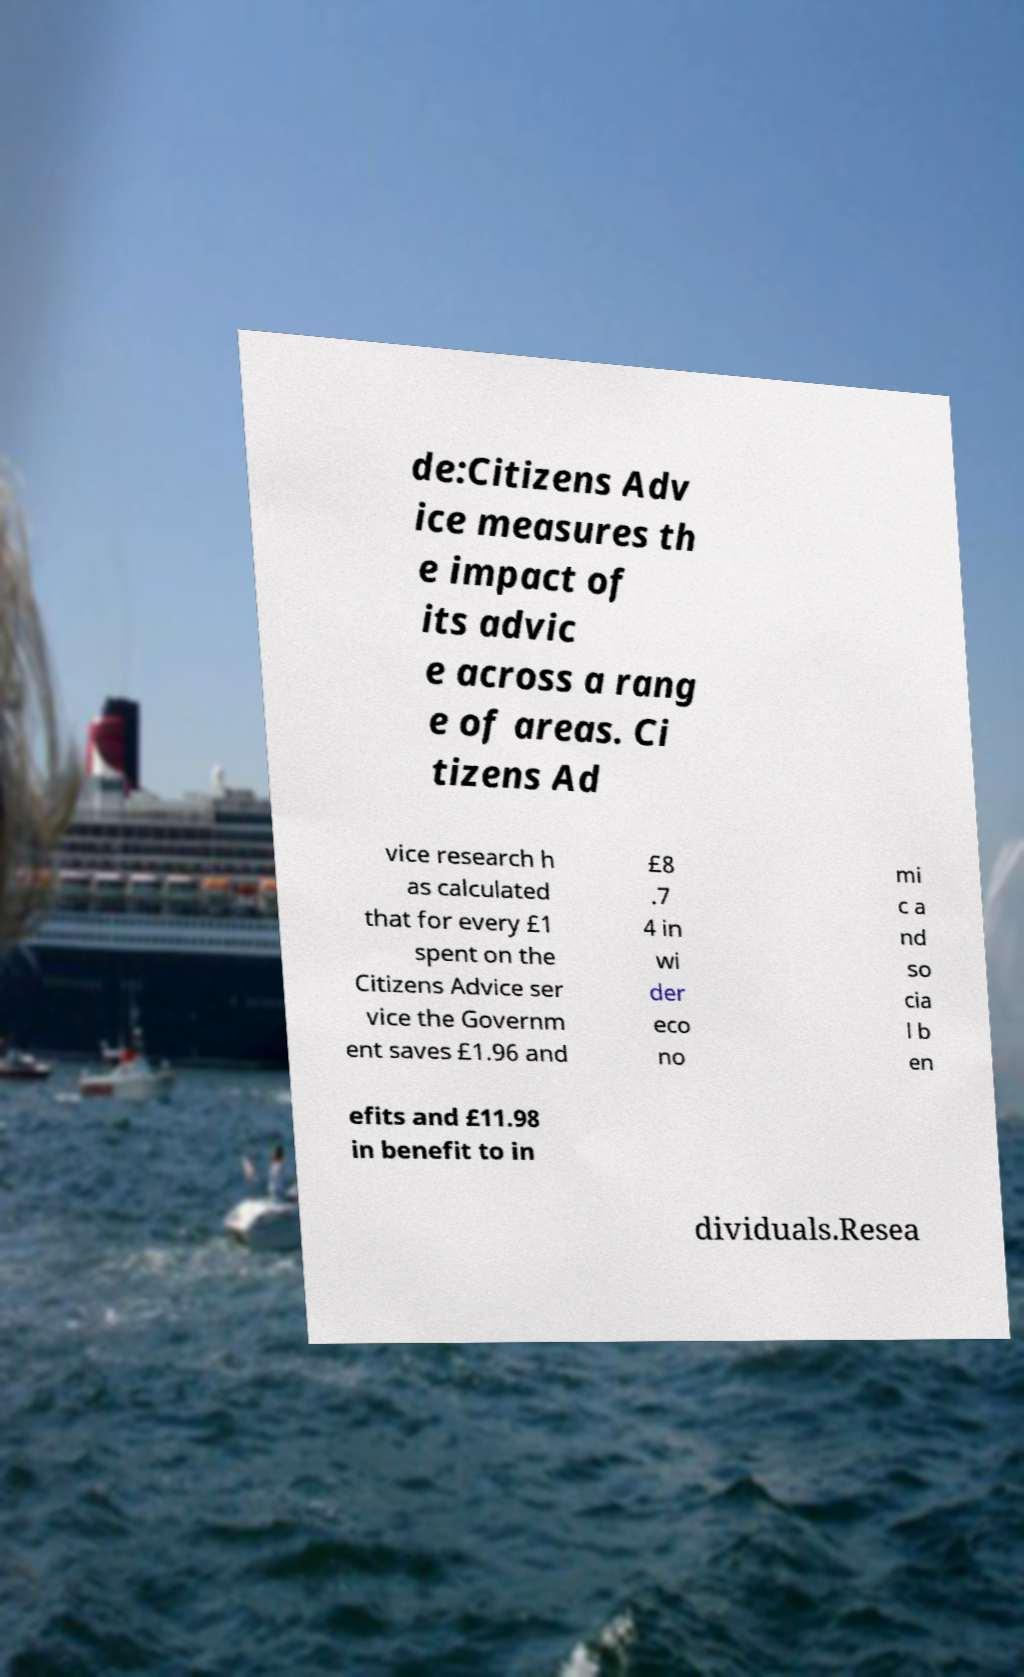What messages or text are displayed in this image? I need them in a readable, typed format. de:Citizens Adv ice measures th e impact of its advic e across a rang e of areas. Ci tizens Ad vice research h as calculated that for every £1 spent on the Citizens Advice ser vice the Governm ent saves £1.96 and £8 .7 4 in wi der eco no mi c a nd so cia l b en efits and £11.98 in benefit to in dividuals.Resea 